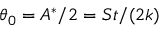<formula> <loc_0><loc_0><loc_500><loc_500>\theta _ { 0 } = A ^ { * } / 2 = S t / ( 2 k )</formula> 